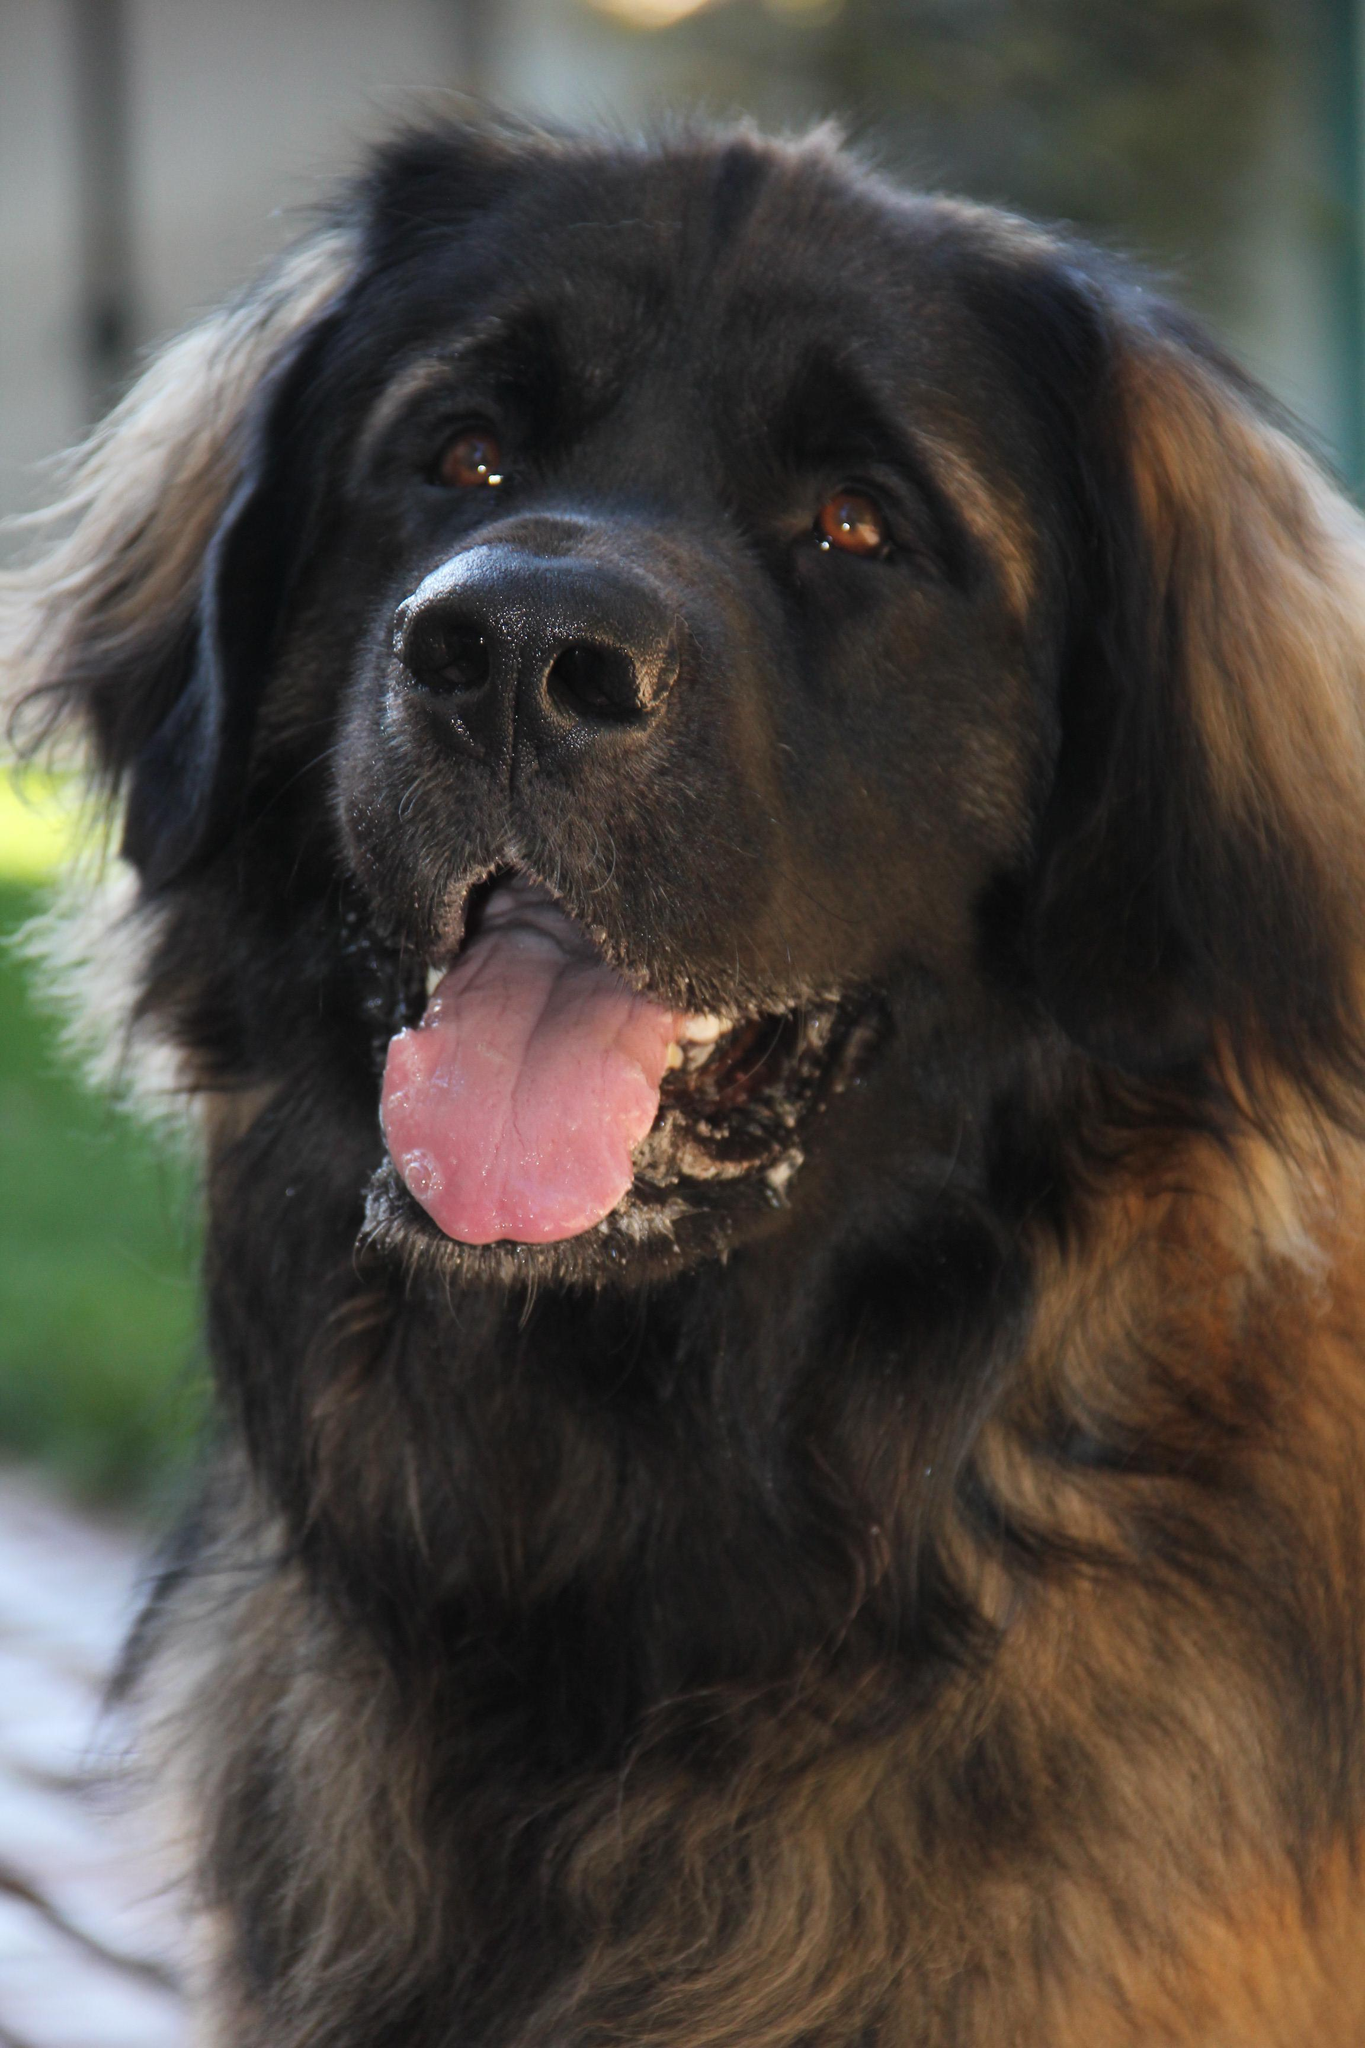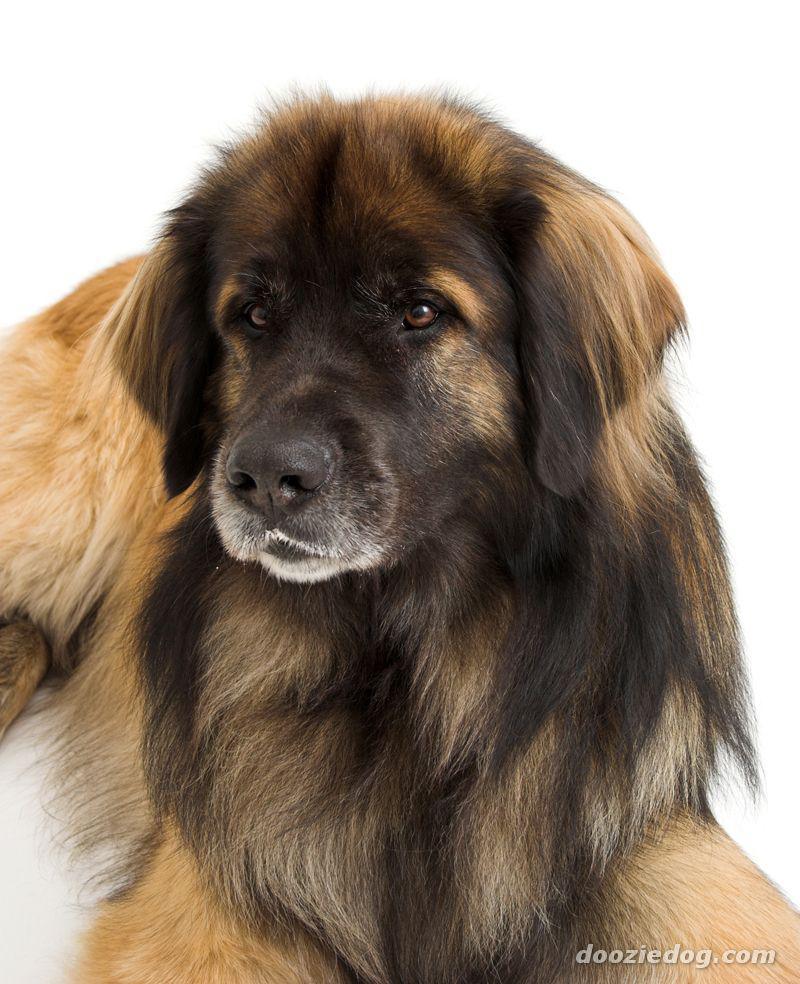The first image is the image on the left, the second image is the image on the right. For the images shown, is this caption "dogs are in a house" true? Answer yes or no. No. 